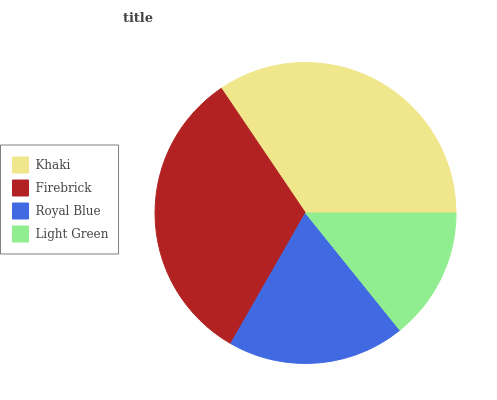Is Light Green the minimum?
Answer yes or no. Yes. Is Khaki the maximum?
Answer yes or no. Yes. Is Firebrick the minimum?
Answer yes or no. No. Is Firebrick the maximum?
Answer yes or no. No. Is Khaki greater than Firebrick?
Answer yes or no. Yes. Is Firebrick less than Khaki?
Answer yes or no. Yes. Is Firebrick greater than Khaki?
Answer yes or no. No. Is Khaki less than Firebrick?
Answer yes or no. No. Is Firebrick the high median?
Answer yes or no. Yes. Is Royal Blue the low median?
Answer yes or no. Yes. Is Royal Blue the high median?
Answer yes or no. No. Is Light Green the low median?
Answer yes or no. No. 